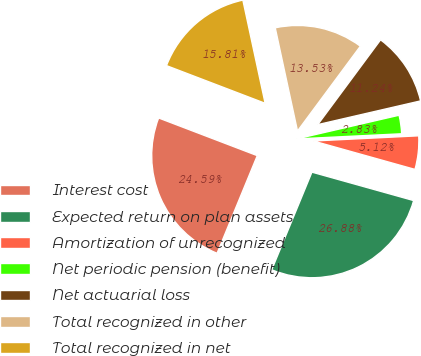Convert chart. <chart><loc_0><loc_0><loc_500><loc_500><pie_chart><fcel>Interest cost<fcel>Expected return on plan assets<fcel>Amortization of unrecognized<fcel>Net periodic pension (benefit)<fcel>Net actuarial loss<fcel>Total recognized in other<fcel>Total recognized in net<nl><fcel>24.59%<fcel>26.88%<fcel>5.12%<fcel>2.83%<fcel>11.24%<fcel>13.53%<fcel>15.81%<nl></chart> 